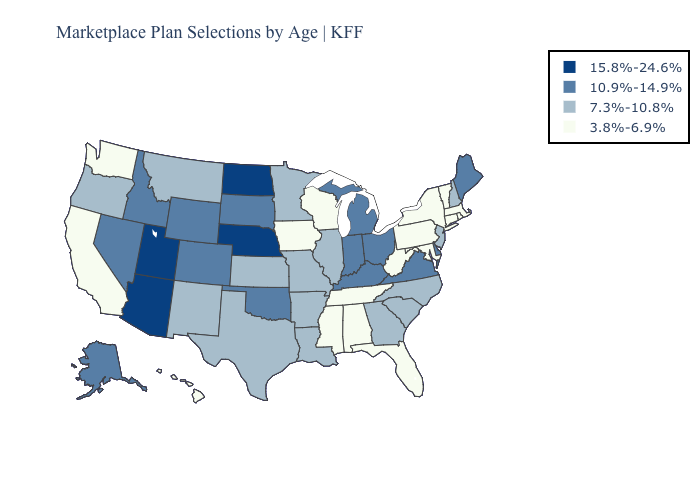Does Nevada have the lowest value in the USA?
Answer briefly. No. What is the value of Utah?
Write a very short answer. 15.8%-24.6%. Does Florida have a higher value than Hawaii?
Keep it brief. No. Does South Dakota have a lower value than Nebraska?
Give a very brief answer. Yes. Which states have the lowest value in the Northeast?
Keep it brief. Connecticut, Massachusetts, New York, Pennsylvania, Rhode Island, Vermont. Which states have the lowest value in the Northeast?
Quick response, please. Connecticut, Massachusetts, New York, Pennsylvania, Rhode Island, Vermont. Does Hawaii have the highest value in the West?
Short answer required. No. Name the states that have a value in the range 7.3%-10.8%?
Give a very brief answer. Arkansas, Georgia, Illinois, Kansas, Louisiana, Minnesota, Missouri, Montana, New Hampshire, New Jersey, New Mexico, North Carolina, Oregon, South Carolina, Texas. What is the value of Hawaii?
Keep it brief. 3.8%-6.9%. Name the states that have a value in the range 10.9%-14.9%?
Keep it brief. Alaska, Colorado, Delaware, Idaho, Indiana, Kentucky, Maine, Michigan, Nevada, Ohio, Oklahoma, South Dakota, Virginia, Wyoming. Does Alaska have a lower value than North Dakota?
Keep it brief. Yes. Name the states that have a value in the range 15.8%-24.6%?
Give a very brief answer. Arizona, Nebraska, North Dakota, Utah. Which states have the highest value in the USA?
Keep it brief. Arizona, Nebraska, North Dakota, Utah. Does Ohio have the lowest value in the USA?
Write a very short answer. No. Name the states that have a value in the range 15.8%-24.6%?
Short answer required. Arizona, Nebraska, North Dakota, Utah. 